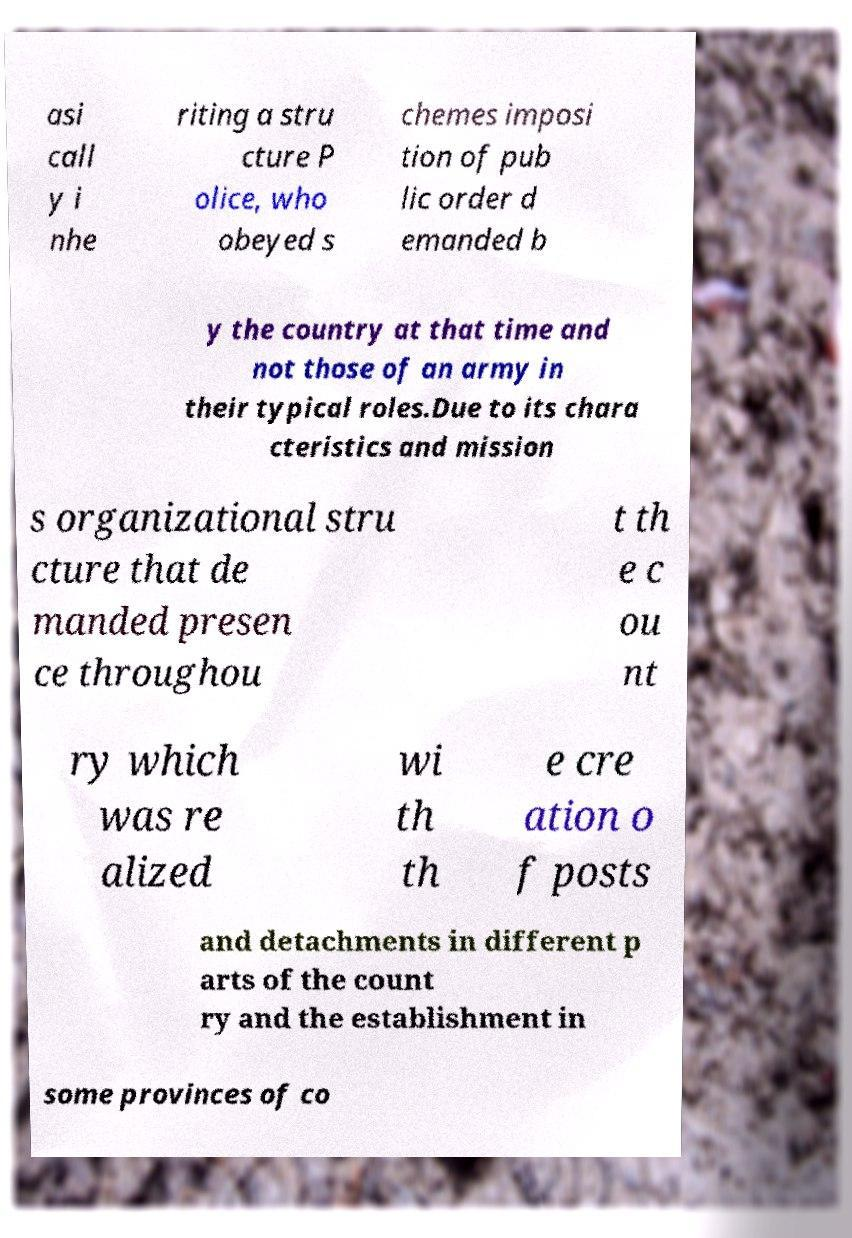What messages or text are displayed in this image? I need them in a readable, typed format. asi call y i nhe riting a stru cture P olice, who obeyed s chemes imposi tion of pub lic order d emanded b y the country at that time and not those of an army in their typical roles.Due to its chara cteristics and mission s organizational stru cture that de manded presen ce throughou t th e c ou nt ry which was re alized wi th th e cre ation o f posts and detachments in different p arts of the count ry and the establishment in some provinces of co 